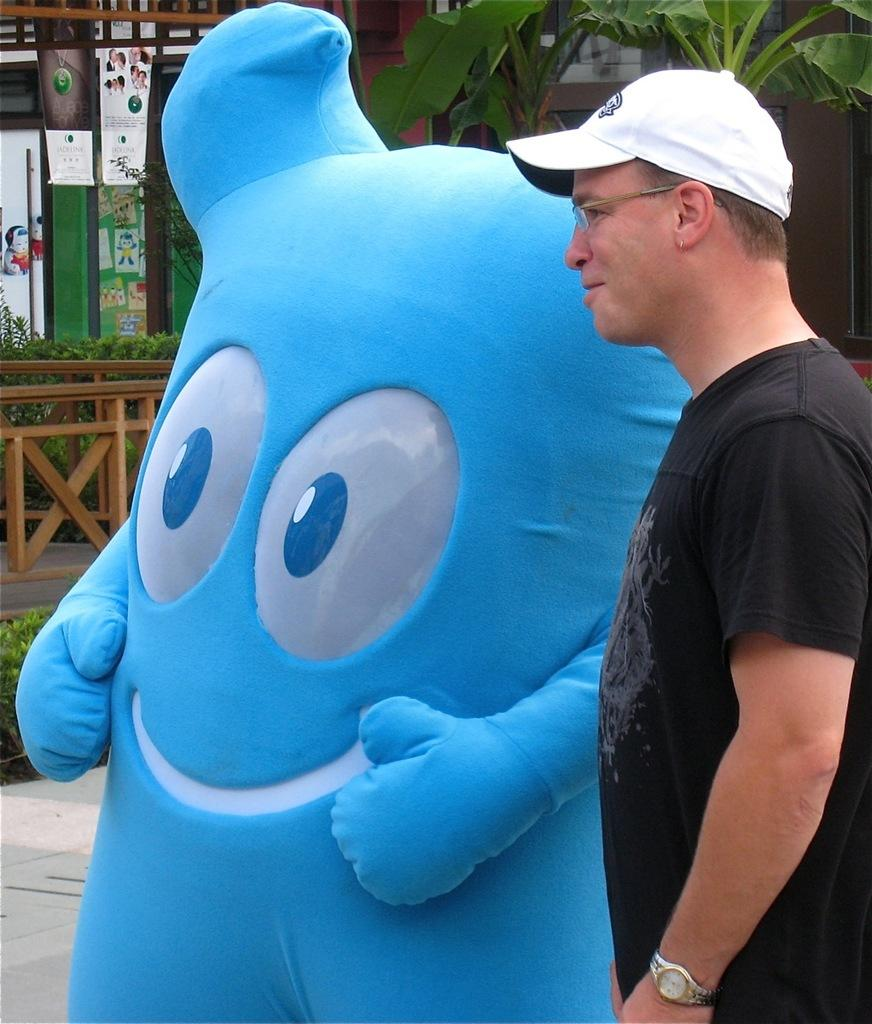Who is present in the image? There is a person in the image. What is the person wearing? The person is wearing clothes, spectacles, and a cap. What is the person doing in the image? The person is standing beside a clown. Where is the tree located in the image? There is a tree in the top right corner of the image. What is the person saying good-bye to in the image? There is no indication in the image that the person is saying good-bye to anyone or anything. What is the cause of death for the person in the image? There is no indication in the image that the person is experiencing or has experienced any form of death. 